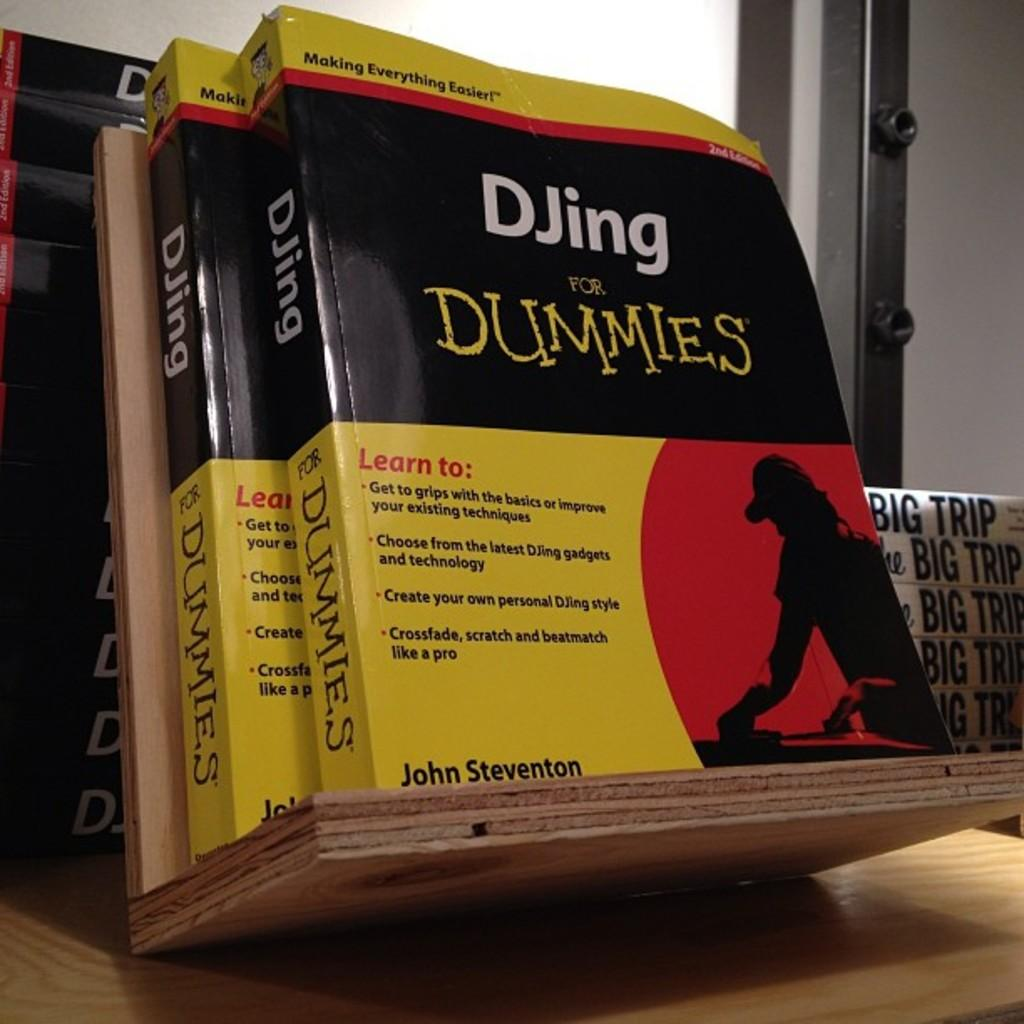<image>
Share a concise interpretation of the image provided. A couple of 'DJing for Dummies' self help books. 